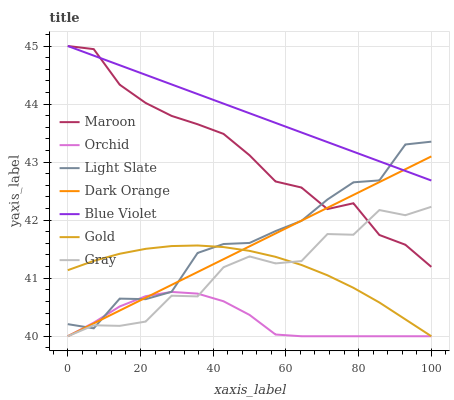Does Gold have the minimum area under the curve?
Answer yes or no. No. Does Gold have the maximum area under the curve?
Answer yes or no. No. Is Gold the smoothest?
Answer yes or no. No. Is Gold the roughest?
Answer yes or no. No. Does Light Slate have the lowest value?
Answer yes or no. No. Does Gold have the highest value?
Answer yes or no. No. Is Gold less than Maroon?
Answer yes or no. Yes. Is Blue Violet greater than Gray?
Answer yes or no. Yes. Does Gold intersect Maroon?
Answer yes or no. No. 